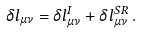<formula> <loc_0><loc_0><loc_500><loc_500>\delta l _ { \mu \nu } = \delta l ^ { I } _ { \mu \nu } + \delta l ^ { S R } _ { \mu \nu } \, .</formula> 